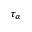Convert formula to latex. <formula><loc_0><loc_0><loc_500><loc_500>\tau _ { \alpha }</formula> 